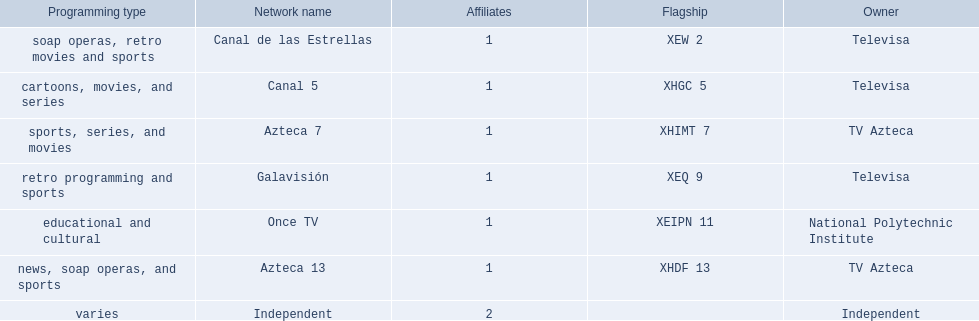Which owner only owns one network? National Polytechnic Institute, Independent. Of those, what is the network name? Once TV, Independent. Of those, which programming type is educational and cultural? Once TV. 